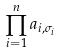Convert formula to latex. <formula><loc_0><loc_0><loc_500><loc_500>\prod _ { i = 1 } ^ { n } a _ { i , \sigma _ { i } }</formula> 